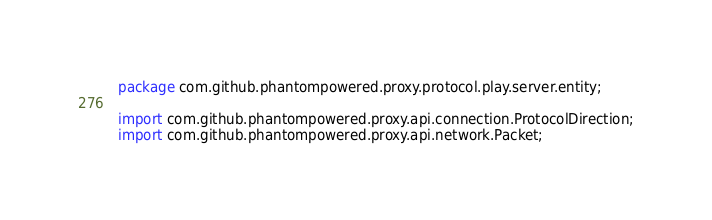<code> <loc_0><loc_0><loc_500><loc_500><_Java_>package com.github.phantompowered.proxy.protocol.play.server.entity;

import com.github.phantompowered.proxy.api.connection.ProtocolDirection;
import com.github.phantompowered.proxy.api.network.Packet;</code> 